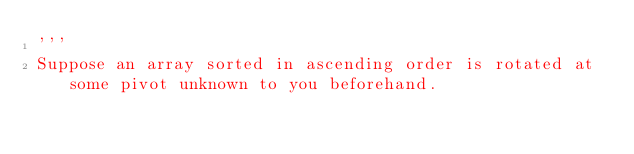Convert code to text. <code><loc_0><loc_0><loc_500><loc_500><_Python_>'''
Suppose an array sorted in ascending order is rotated at some pivot unknown to you beforehand.
</code> 